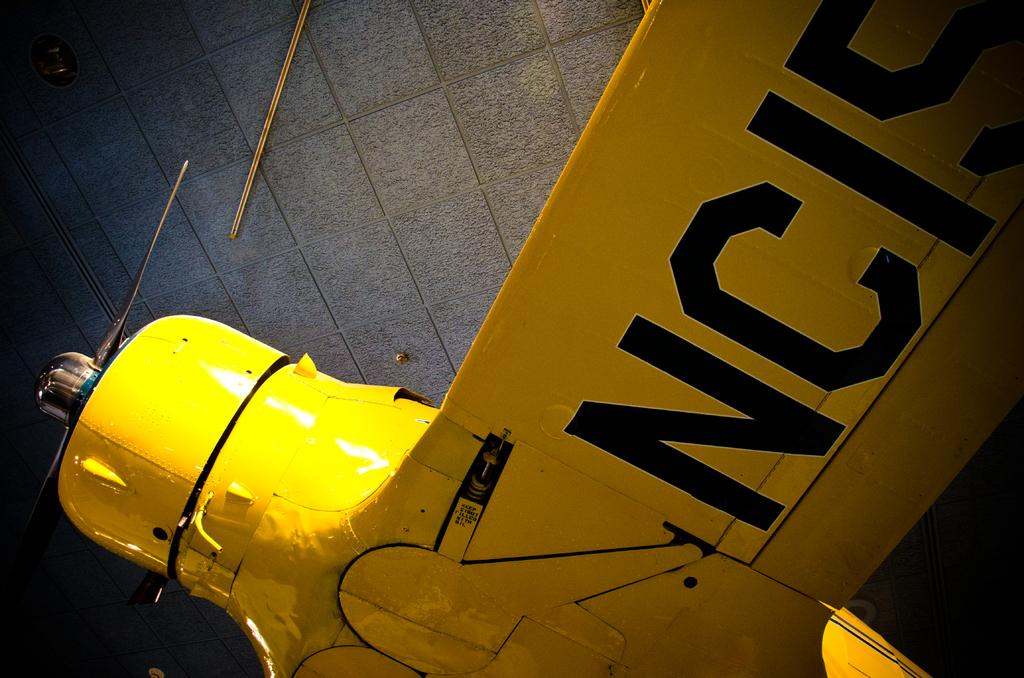<image>
Summarize the visual content of the image. A yellow apparatus with NC15 written in black on it appears to be a plane 